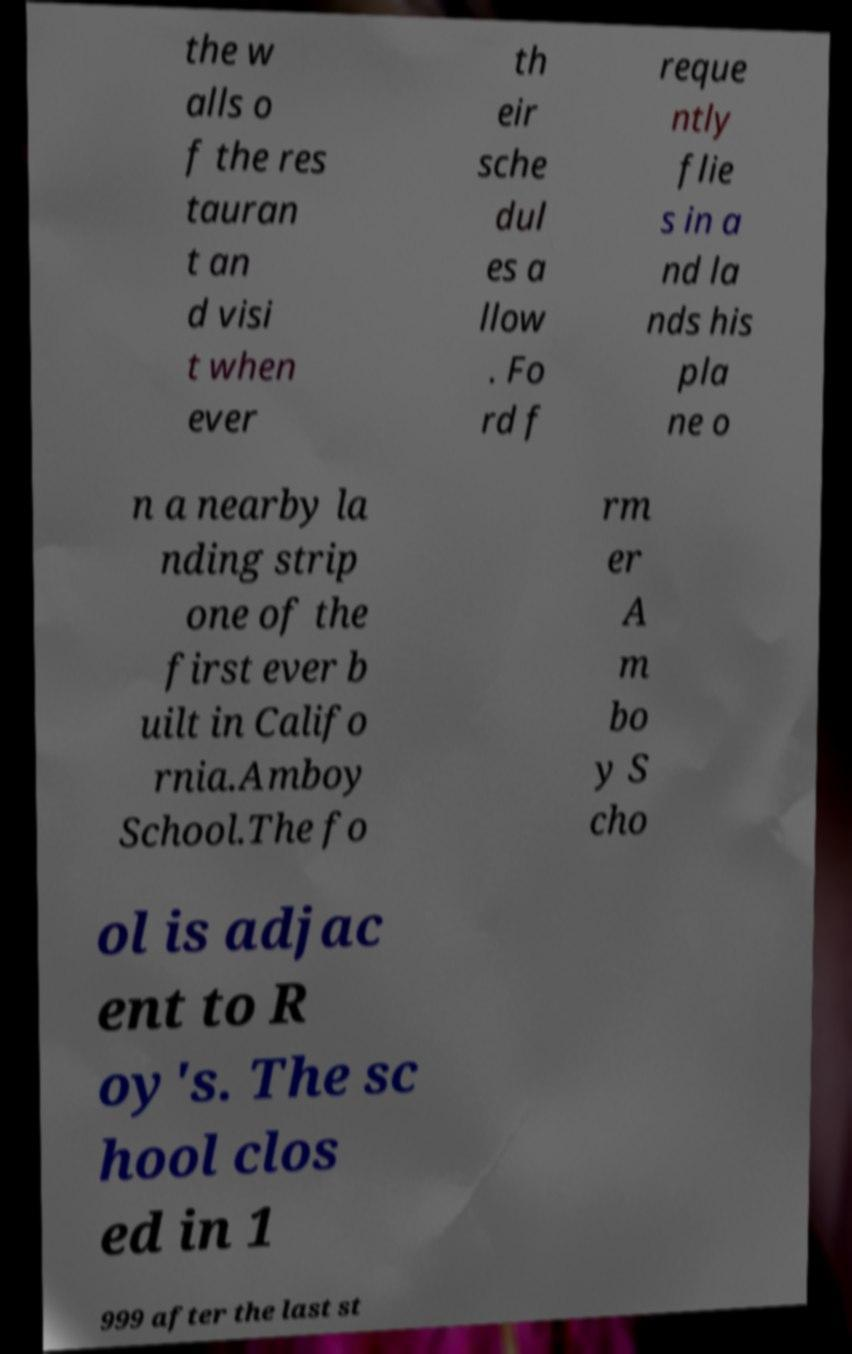I need the written content from this picture converted into text. Can you do that? the w alls o f the res tauran t an d visi t when ever th eir sche dul es a llow . Fo rd f reque ntly flie s in a nd la nds his pla ne o n a nearby la nding strip one of the first ever b uilt in Califo rnia.Amboy School.The fo rm er A m bo y S cho ol is adjac ent to R oy's. The sc hool clos ed in 1 999 after the last st 